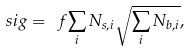<formula> <loc_0><loc_0><loc_500><loc_500>\ s i g = \ f { \sum _ { i } N _ { s , i } } { \sqrt { \sum _ { i } N _ { b , i } } } ,</formula> 